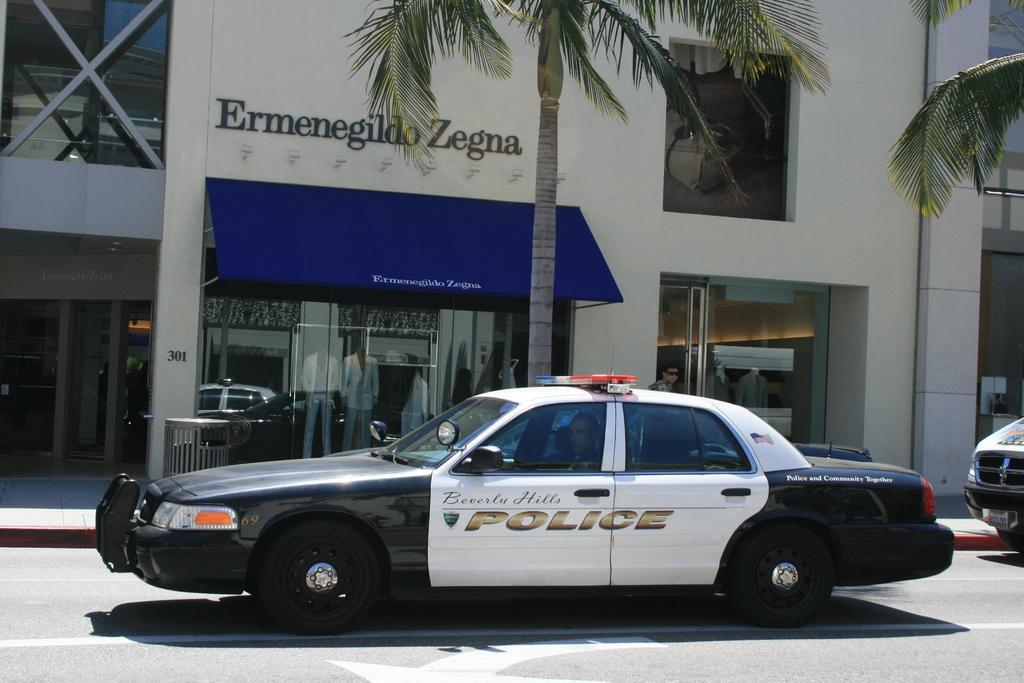Describe this image in one or two sentences. In this picture we can see few vehicles on the road, few people are seated in the car, in the background we can find few trees, buildings, metal rods and mannequins. 